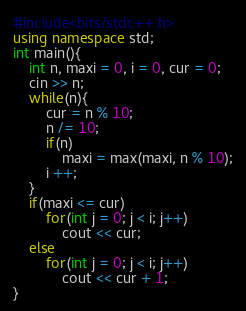<code> <loc_0><loc_0><loc_500><loc_500><_C++_>#include<bits/stdc++.h>
using namespace std;
int main(){
	int n, maxi = 0, i = 0, cur = 0;
	cin >> n;
	while(n){
		cur = n % 10;
		n /= 10;
		if(n)
			maxi = max(maxi, n % 10);
		i ++;
	}
	if(maxi <= cur)
		for(int j = 0; j < i; j++)
			cout << cur;
	else
		for(int j = 0; j < i; j++)
			cout << cur + 1;
}</code> 